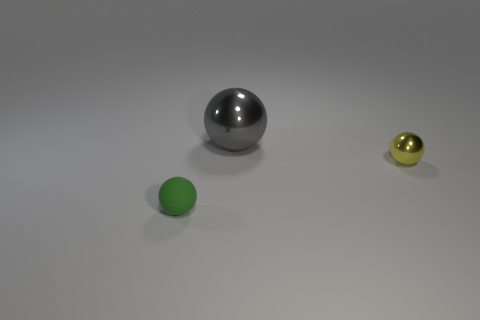What number of large shiny spheres are in front of the ball in front of the tiny metal ball?
Make the answer very short. 0. What is the size of the thing that is behind the small rubber sphere and left of the tiny yellow ball?
Ensure brevity in your answer.  Large. How many metal objects are either tiny cyan spheres or gray spheres?
Offer a terse response. 1. What material is the green ball?
Your answer should be compact. Rubber. The thing to the left of the shiny ball behind the small sphere that is to the right of the tiny green matte sphere is made of what material?
Offer a terse response. Rubber. What shape is the green object that is the same size as the yellow ball?
Offer a terse response. Sphere. What number of objects are small red objects or things in front of the gray metal thing?
Your answer should be compact. 2. Do the tiny thing that is left of the gray object and the tiny thing right of the big gray metallic thing have the same material?
Your answer should be very brief. No. How many purple objects are either shiny spheres or balls?
Offer a very short reply. 0. What size is the green object?
Give a very brief answer. Small. 